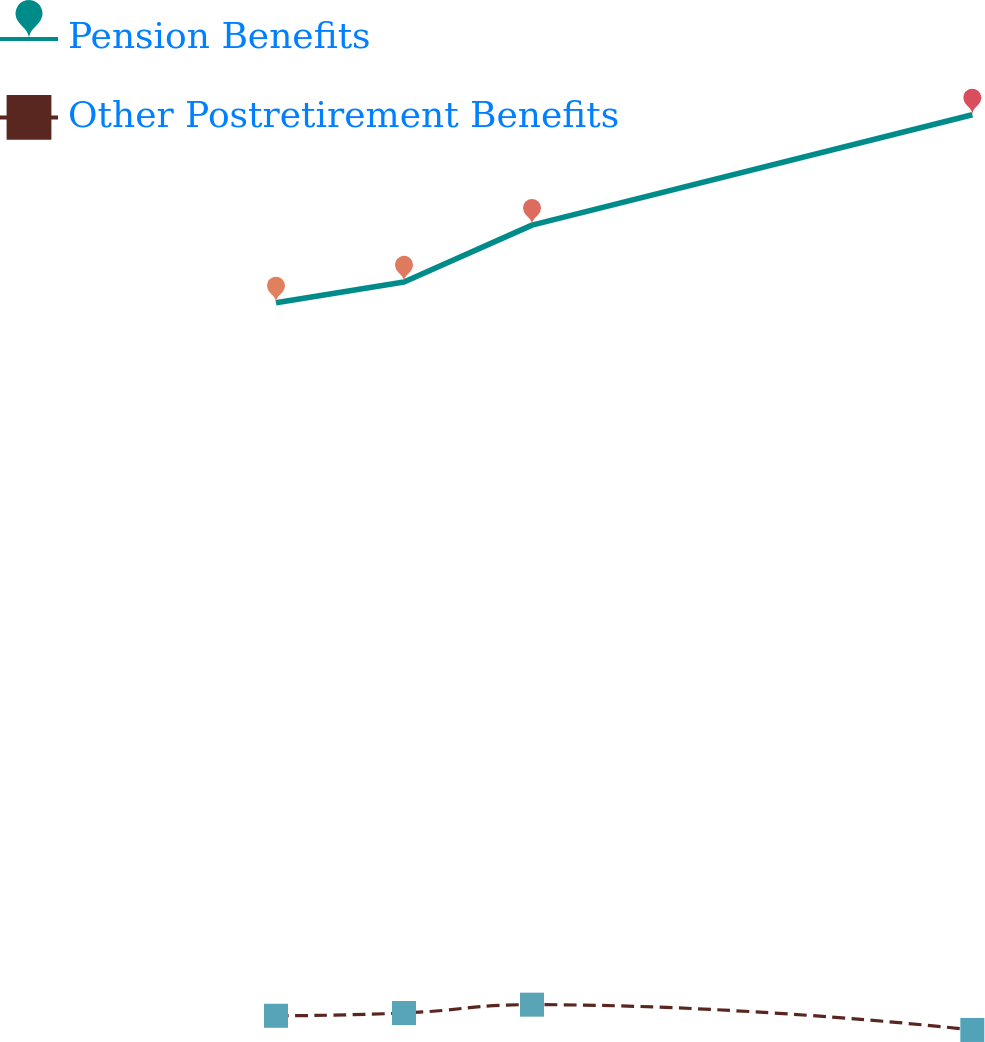<chart> <loc_0><loc_0><loc_500><loc_500><line_chart><ecel><fcel>Pension Benefits<fcel>Other Postretirement Benefits<nl><fcel>1710.51<fcel>95896<fcel>6776.6<nl><fcel>1780.69<fcel>98507.4<fcel>7127.92<nl><fcel>1850.87<fcel>105613<fcel>8167.33<nl><fcel>2092.31<fcel>119398<fcel>5005.43<nl><fcel>2412.33<fcel>93284.6<fcel>4654.11<nl></chart> 